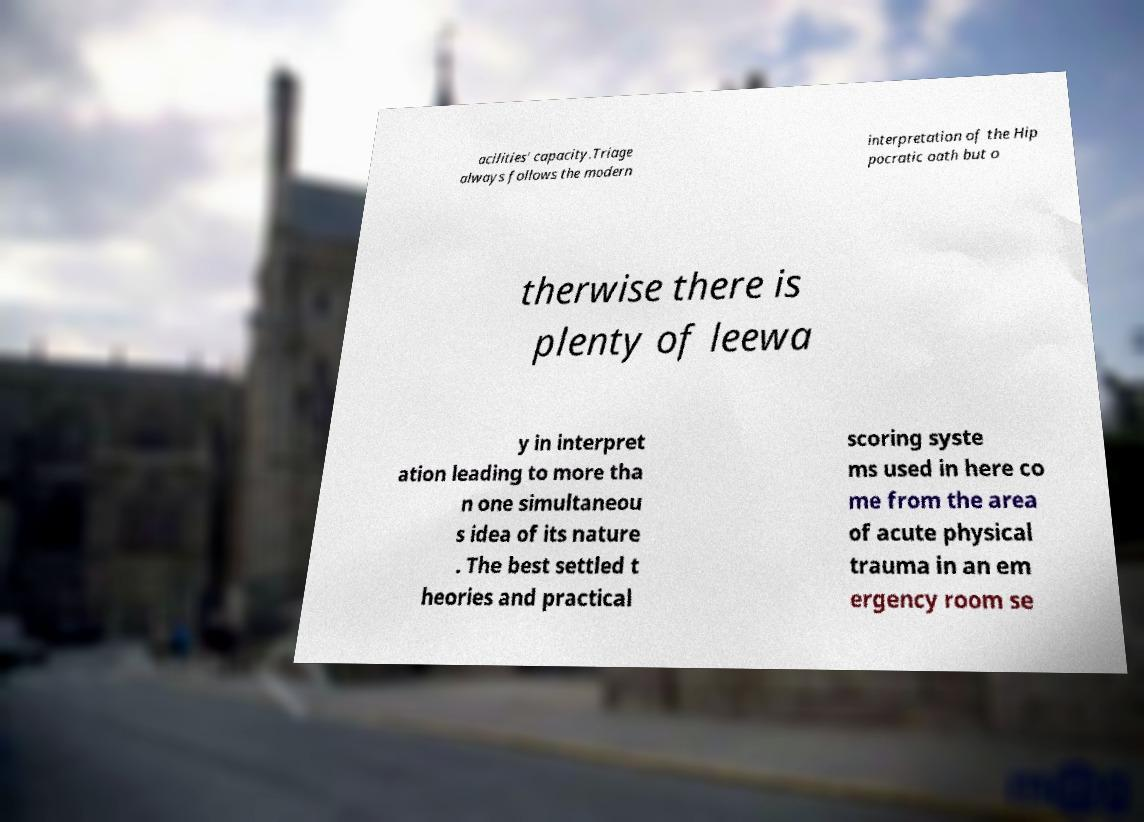Can you accurately transcribe the text from the provided image for me? acilities' capacity.Triage always follows the modern interpretation of the Hip pocratic oath but o therwise there is plenty of leewa y in interpret ation leading to more tha n one simultaneou s idea of its nature . The best settled t heories and practical scoring syste ms used in here co me from the area of acute physical trauma in an em ergency room se 